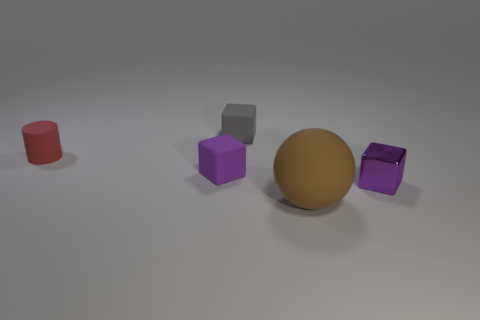What is the material of the other small thing that is the same color as the shiny thing?
Keep it short and to the point. Rubber. There is a matte block that is the same color as the tiny metallic cube; what size is it?
Your response must be concise. Small. What number of tiny matte cylinders are the same color as the big rubber thing?
Give a very brief answer. 0. The thing that is both behind the small purple rubber object and in front of the gray object has what shape?
Ensure brevity in your answer.  Cylinder. Is there a metal cylinder that has the same size as the brown rubber sphere?
Offer a very short reply. No. What number of things are either purple things to the left of the brown thing or red rubber cylinders?
Your response must be concise. 2. Is the tiny red thing made of the same material as the tiny cube that is in front of the tiny purple rubber thing?
Make the answer very short. No. What number of other objects are there of the same shape as the tiny purple shiny thing?
Keep it short and to the point. 2. How many objects are tiny cubes behind the purple metal block or tiny purple objects behind the purple metal thing?
Offer a terse response. 2. What number of other things are there of the same color as the large rubber sphere?
Ensure brevity in your answer.  0. 